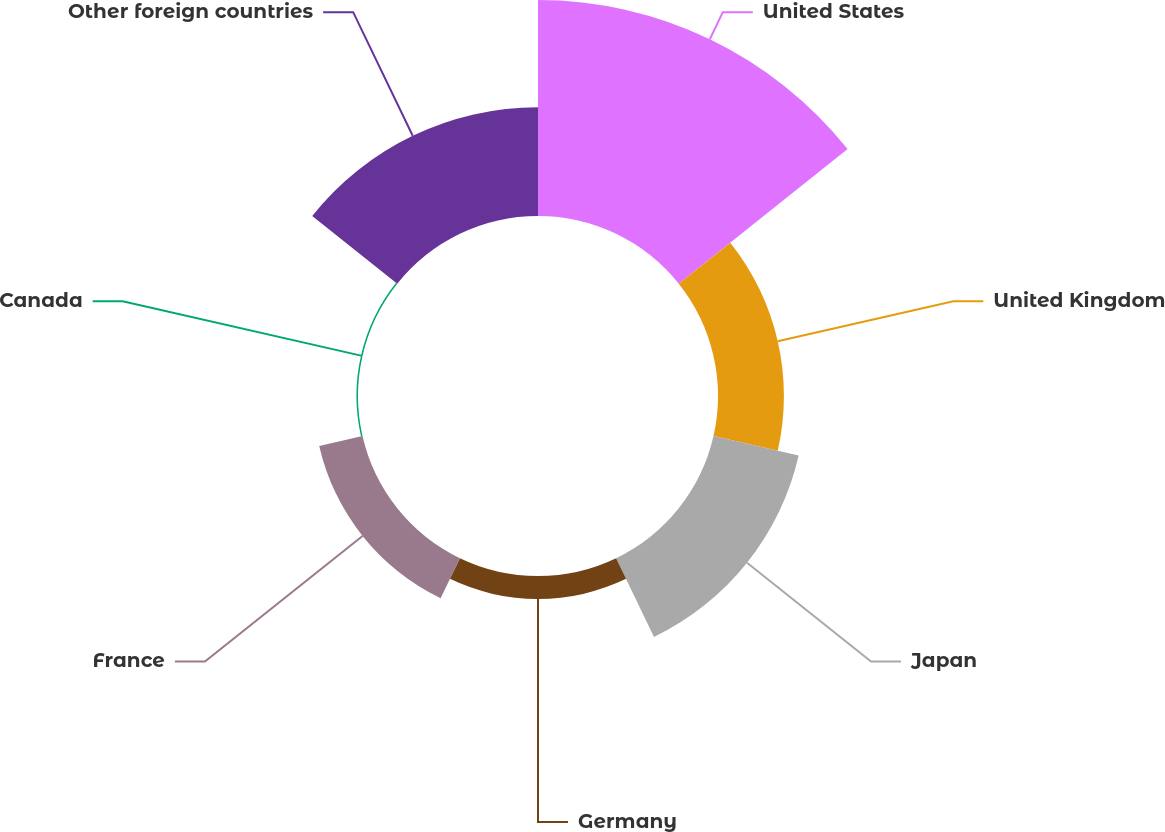Convert chart to OTSL. <chart><loc_0><loc_0><loc_500><loc_500><pie_chart><fcel>United States<fcel>United Kingdom<fcel>Japan<fcel>Germany<fcel>France<fcel>Canada<fcel>Other foreign countries<nl><fcel>39.49%<fcel>12.05%<fcel>15.97%<fcel>4.2%<fcel>8.12%<fcel>0.28%<fcel>19.89%<nl></chart> 